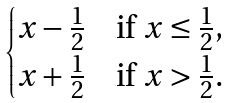<formula> <loc_0><loc_0><loc_500><loc_500>\begin{cases} x - \frac { 1 } { 2 } & \text {if $x\leq\frac{1}{2}$} , \\ x + \frac { 1 } { 2 } & \text {if $x>\frac{1}{2}$} . \end{cases}</formula> 